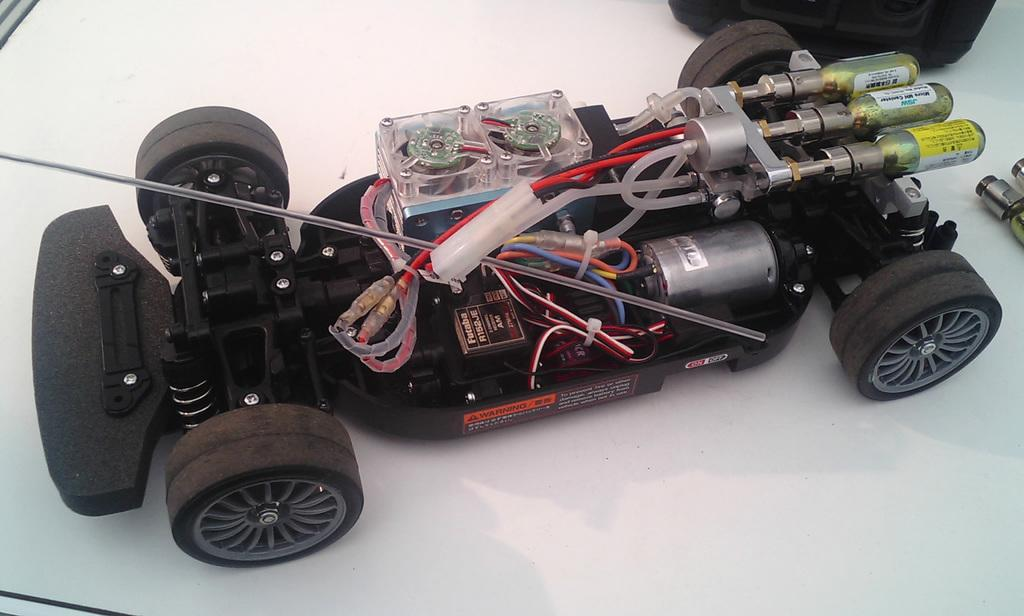What type of car is in the image? There is a remote car in the image. What else can be seen in the image besides the car? There are objects on a table in the image. What type of brick is being used to build the baby's crib in the image? There is no brick or baby's crib present in the image. What genre of fiction is being read by the characters in the image? There are no characters or fiction books present in the image. 